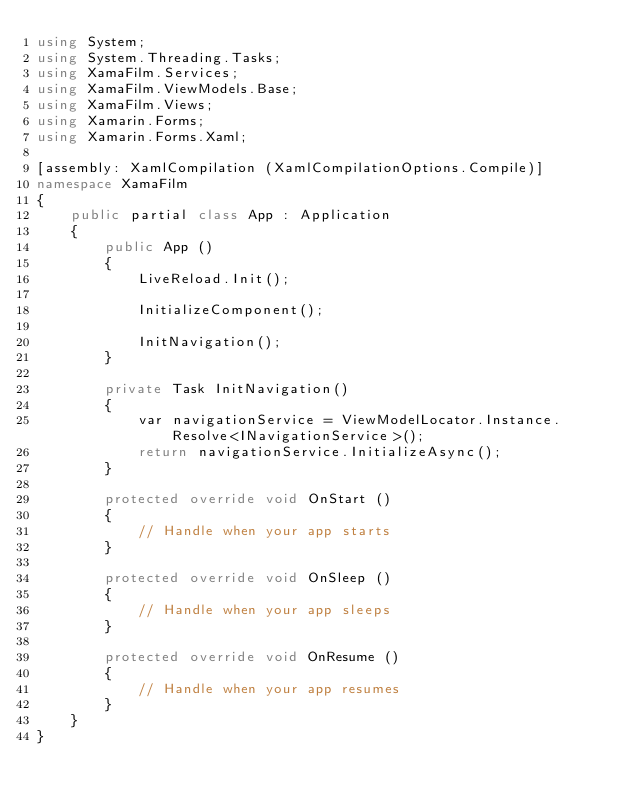Convert code to text. <code><loc_0><loc_0><loc_500><loc_500><_C#_>using System;
using System.Threading.Tasks;
using XamaFilm.Services;
using XamaFilm.ViewModels.Base;
using XamaFilm.Views;
using Xamarin.Forms;
using Xamarin.Forms.Xaml;

[assembly: XamlCompilation (XamlCompilationOptions.Compile)]
namespace XamaFilm
{
	public partial class App : Application
	{
		public App ()
		{
            LiveReload.Init();

			InitializeComponent();

            InitNavigation();
        }

        private Task InitNavigation()
        {
            var navigationService = ViewModelLocator.Instance.Resolve<INavigationService>();
            return navigationService.InitializeAsync();
        }

        protected override void OnStart ()
		{
			// Handle when your app starts
		}

		protected override void OnSleep ()
		{
			// Handle when your app sleeps
		}

		protected override void OnResume ()
		{
			// Handle when your app resumes
		}
	}
}
</code> 